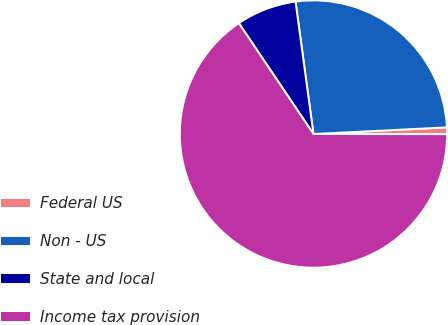Convert chart. <chart><loc_0><loc_0><loc_500><loc_500><pie_chart><fcel>Federal US<fcel>Non - US<fcel>State and local<fcel>Income tax provision<nl><fcel>0.81%<fcel>26.35%<fcel>7.28%<fcel>65.56%<nl></chart> 